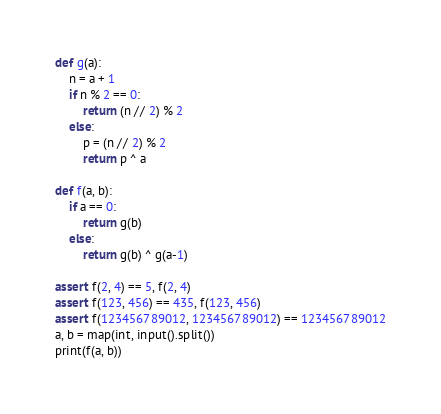<code> <loc_0><loc_0><loc_500><loc_500><_Python_>def g(a):
    n = a + 1
    if n % 2 == 0:
        return (n // 2) % 2
    else:
        p = (n // 2) % 2
        return p ^ a

def f(a, b):
    if a == 0:
        return g(b)
    else:
        return g(b) ^ g(a-1)

assert f(2, 4) == 5, f(2, 4)
assert f(123, 456) == 435, f(123, 456)
assert f(123456789012, 123456789012) == 123456789012
a, b = map(int, input().split())
print(f(a, b))</code> 